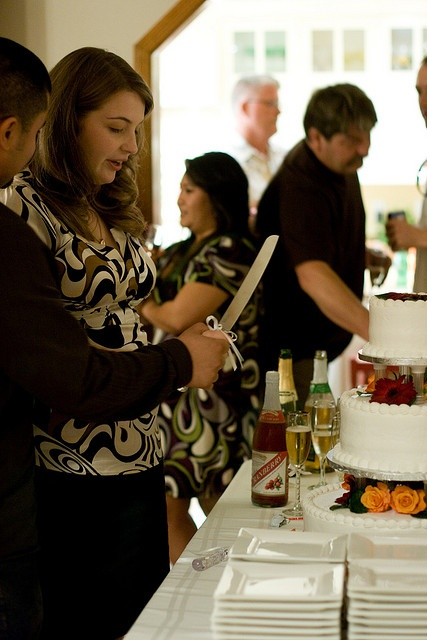Describe the objects in this image and their specific colors. I can see people in olive, black, maroon, and brown tones, people in maroon, black, and brown tones, people in maroon, black, and brown tones, people in olive, black, brown, and maroon tones, and dining table in maroon, darkgray, tan, and lightgray tones in this image. 